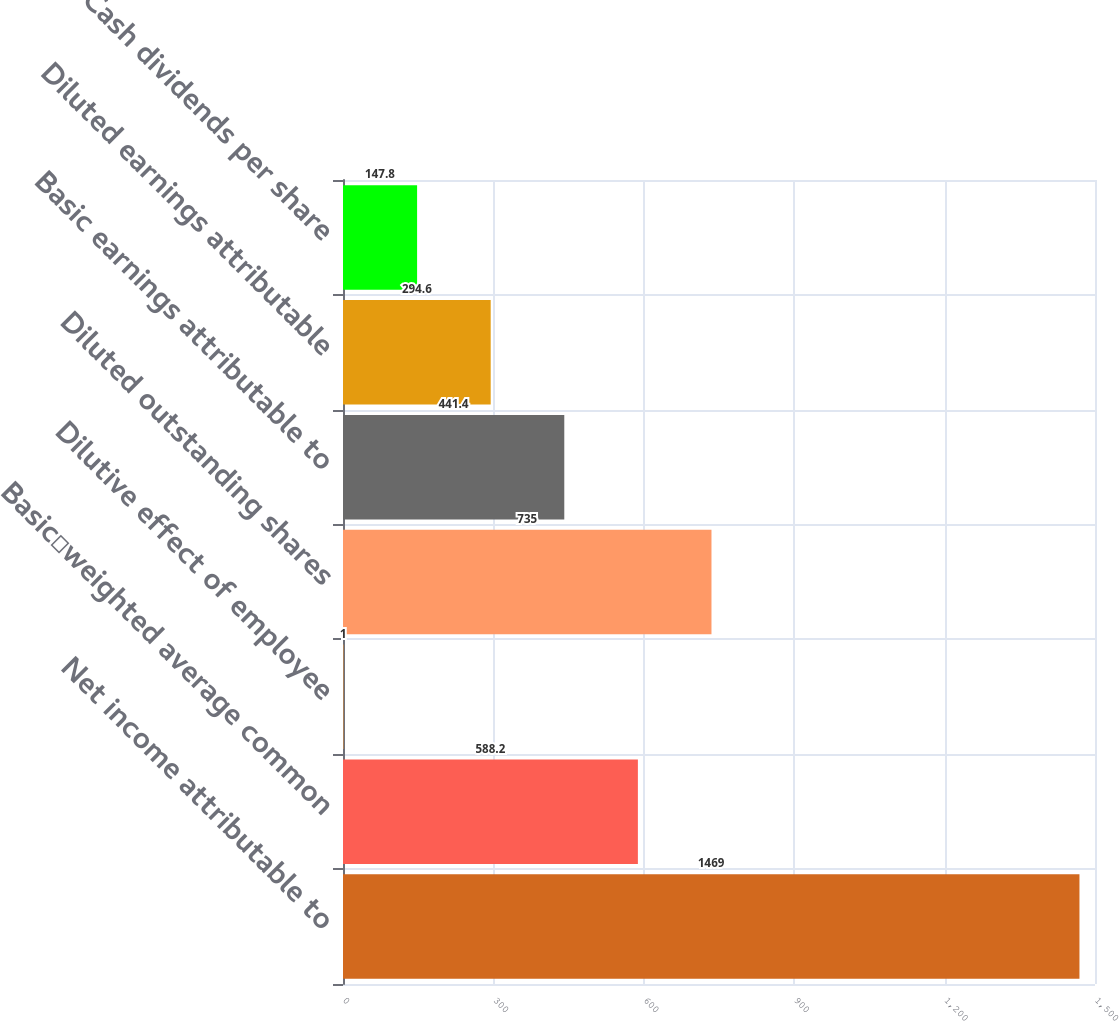<chart> <loc_0><loc_0><loc_500><loc_500><bar_chart><fcel>Net income attributable to<fcel>Basicweighted average common<fcel>Dilutive effect of employee<fcel>Diluted outstanding shares<fcel>Basic earnings attributable to<fcel>Diluted earnings attributable<fcel>Cash dividends per share<nl><fcel>1469<fcel>588.2<fcel>1<fcel>735<fcel>441.4<fcel>294.6<fcel>147.8<nl></chart> 